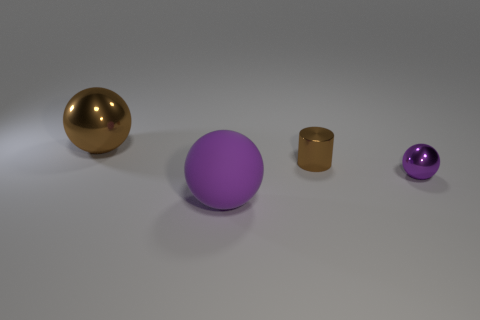Are there any other things that have the same color as the matte ball?
Provide a succinct answer. Yes. Are there fewer purple balls to the left of the tiny purple sphere than big cylinders?
Your answer should be compact. No. How many yellow spheres are the same size as the cylinder?
Your answer should be compact. 0. What is the shape of the metallic thing that is the same color as the big matte object?
Ensure brevity in your answer.  Sphere. What is the shape of the metal thing that is on the right side of the brown thing on the right side of the thing that is left of the big purple object?
Your response must be concise. Sphere. There is a shiny ball that is in front of the cylinder; what is its color?
Provide a short and direct response. Purple. What number of things are small cylinders on the right side of the large brown sphere or large brown metallic objects behind the tiny brown metallic object?
Your answer should be very brief. 2. What number of big matte objects have the same shape as the small brown object?
Provide a short and direct response. 0. There is a shiny sphere that is the same size as the cylinder; what is its color?
Your answer should be very brief. Purple. What is the color of the metallic ball that is on the left side of the large ball in front of the shiny object that is in front of the small brown object?
Keep it short and to the point. Brown. 